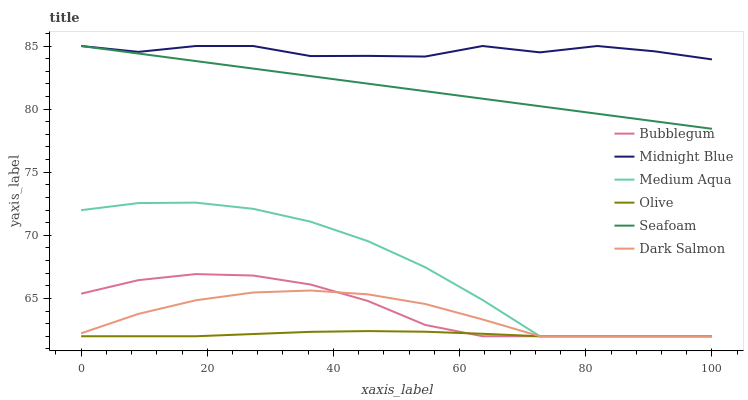Does Olive have the minimum area under the curve?
Answer yes or no. Yes. Does Midnight Blue have the maximum area under the curve?
Answer yes or no. Yes. Does Dark Salmon have the minimum area under the curve?
Answer yes or no. No. Does Dark Salmon have the maximum area under the curve?
Answer yes or no. No. Is Seafoam the smoothest?
Answer yes or no. Yes. Is Midnight Blue the roughest?
Answer yes or no. Yes. Is Dark Salmon the smoothest?
Answer yes or no. No. Is Dark Salmon the roughest?
Answer yes or no. No. Does Dark Salmon have the lowest value?
Answer yes or no. Yes. Does Seafoam have the lowest value?
Answer yes or no. No. Does Seafoam have the highest value?
Answer yes or no. Yes. Does Dark Salmon have the highest value?
Answer yes or no. No. Is Dark Salmon less than Midnight Blue?
Answer yes or no. Yes. Is Seafoam greater than Dark Salmon?
Answer yes or no. Yes. Does Midnight Blue intersect Seafoam?
Answer yes or no. Yes. Is Midnight Blue less than Seafoam?
Answer yes or no. No. Is Midnight Blue greater than Seafoam?
Answer yes or no. No. Does Dark Salmon intersect Midnight Blue?
Answer yes or no. No. 